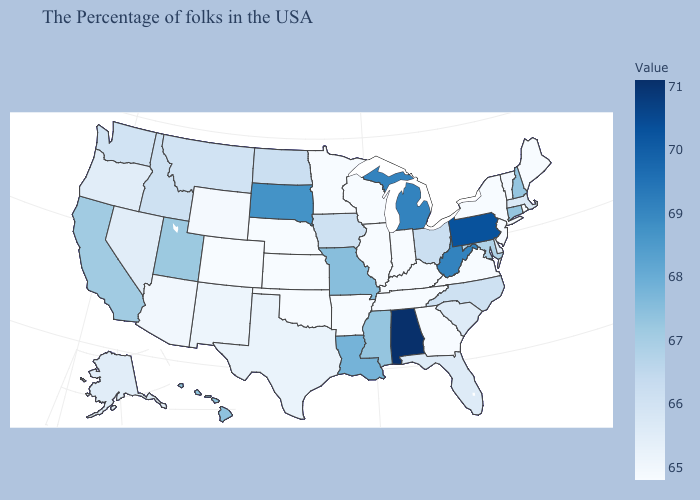Among the states that border Nebraska , which have the lowest value?
Quick response, please. Kansas, Colorado. Among the states that border Virginia , which have the highest value?
Short answer required. West Virginia. Does Washington have the lowest value in the USA?
Quick response, please. No. Among the states that border Iowa , does Minnesota have the lowest value?
Quick response, please. Yes. Does Wisconsin have the highest value in the MidWest?
Short answer required. No. Among the states that border Illinois , which have the highest value?
Write a very short answer. Missouri. Does the map have missing data?
Be succinct. No. 